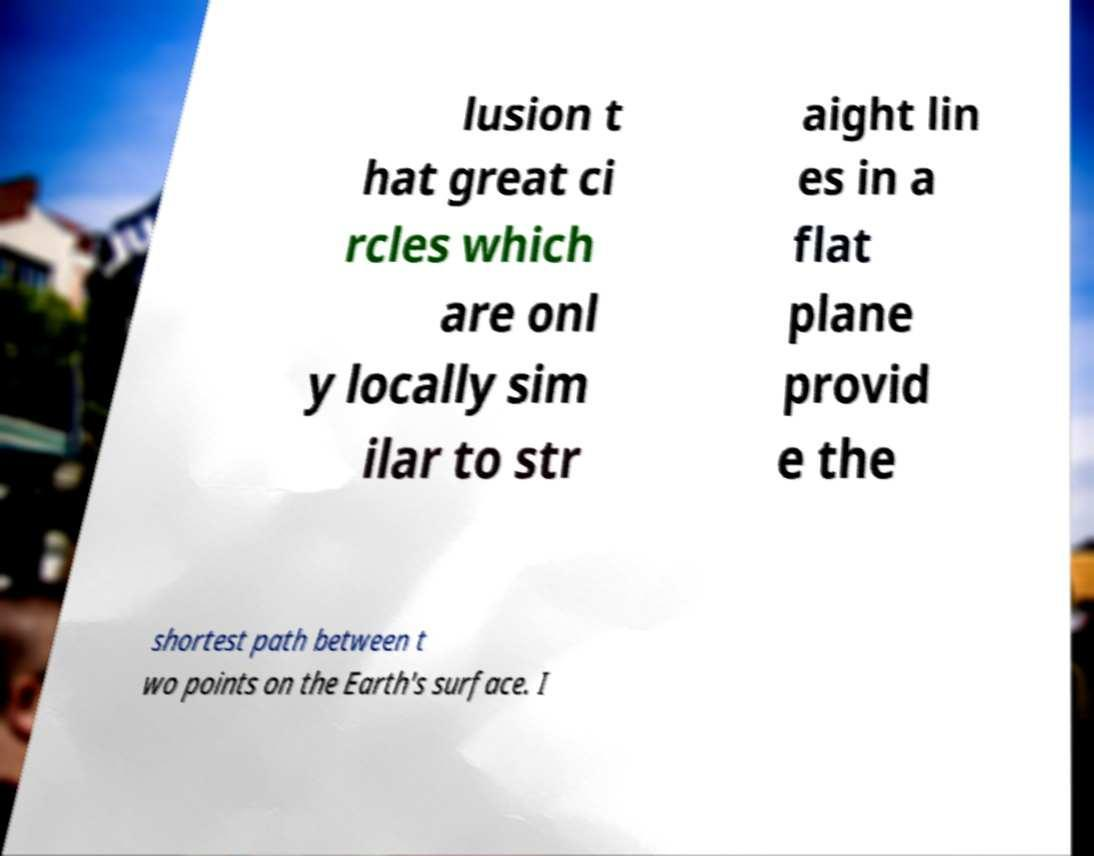Please read and relay the text visible in this image. What does it say? lusion t hat great ci rcles which are onl y locally sim ilar to str aight lin es in a flat plane provid e the shortest path between t wo points on the Earth's surface. I 